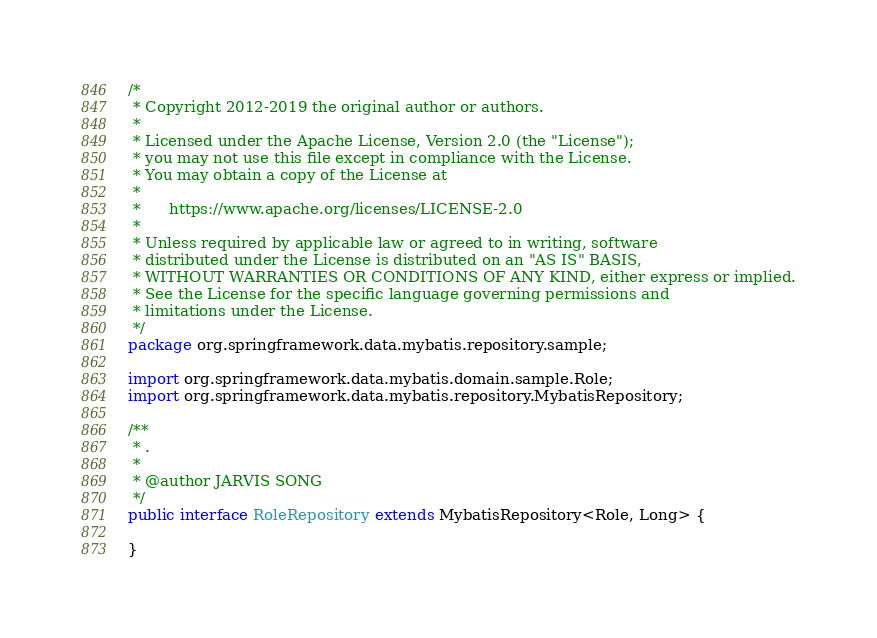<code> <loc_0><loc_0><loc_500><loc_500><_Java_>/*
 * Copyright 2012-2019 the original author or authors.
 *
 * Licensed under the Apache License, Version 2.0 (the "License");
 * you may not use this file except in compliance with the License.
 * You may obtain a copy of the License at
 *
 *      https://www.apache.org/licenses/LICENSE-2.0
 *
 * Unless required by applicable law or agreed to in writing, software
 * distributed under the License is distributed on an "AS IS" BASIS,
 * WITHOUT WARRANTIES OR CONDITIONS OF ANY KIND, either express or implied.
 * See the License for the specific language governing permissions and
 * limitations under the License.
 */
package org.springframework.data.mybatis.repository.sample;

import org.springframework.data.mybatis.domain.sample.Role;
import org.springframework.data.mybatis.repository.MybatisRepository;

/**
 * .
 *
 * @author JARVIS SONG
 */
public interface RoleRepository extends MybatisRepository<Role, Long> {

}
</code> 